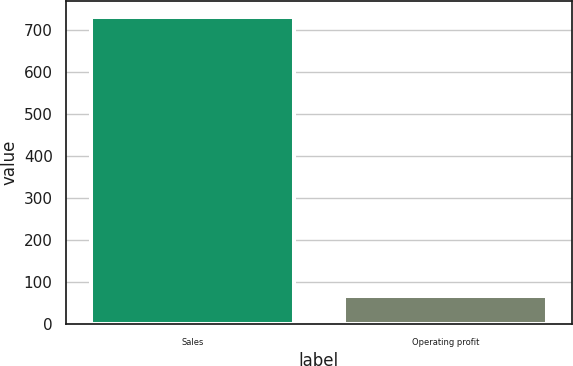Convert chart to OTSL. <chart><loc_0><loc_0><loc_500><loc_500><bar_chart><fcel>Sales<fcel>Operating profit<nl><fcel>731.3<fcel>68.2<nl></chart> 